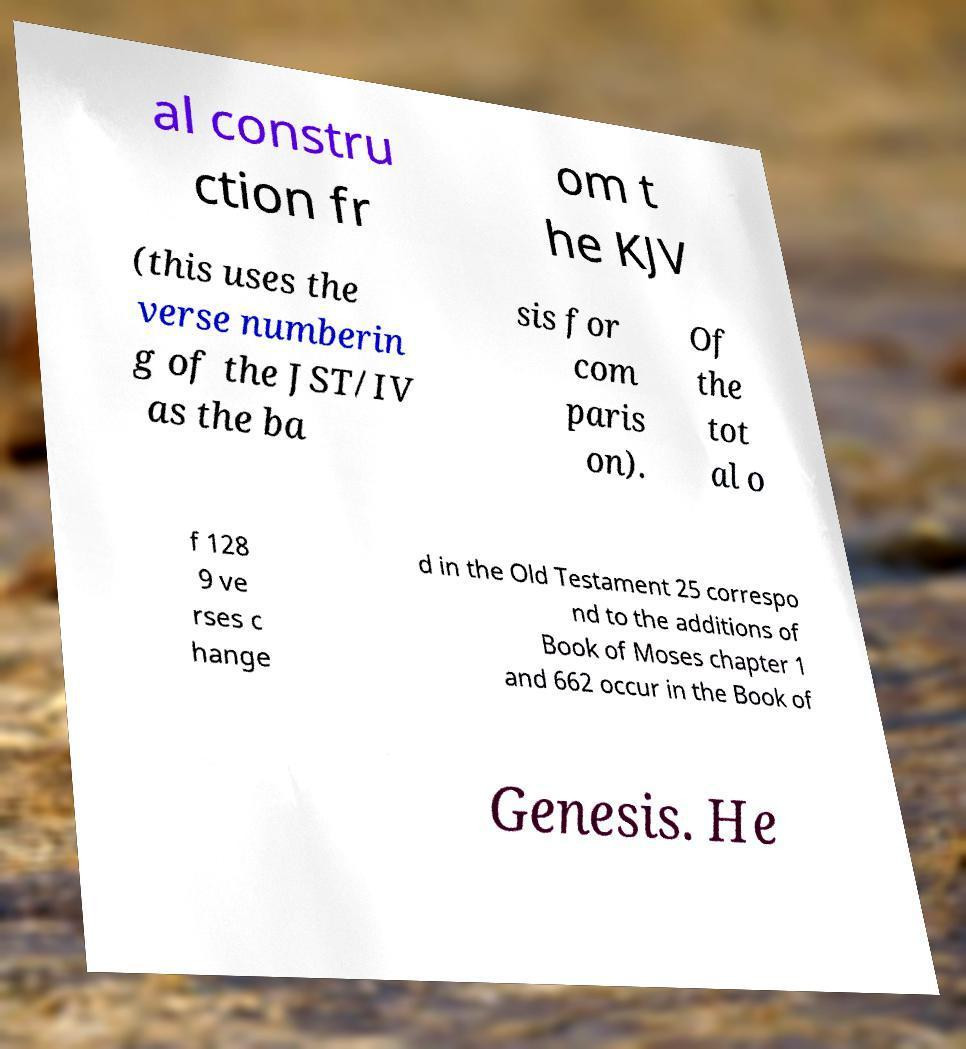Please read and relay the text visible in this image. What does it say? al constru ction fr om t he KJV (this uses the verse numberin g of the JST/IV as the ba sis for com paris on). Of the tot al o f 128 9 ve rses c hange d in the Old Testament 25 correspo nd to the additions of Book of Moses chapter 1 and 662 occur in the Book of Genesis. He 